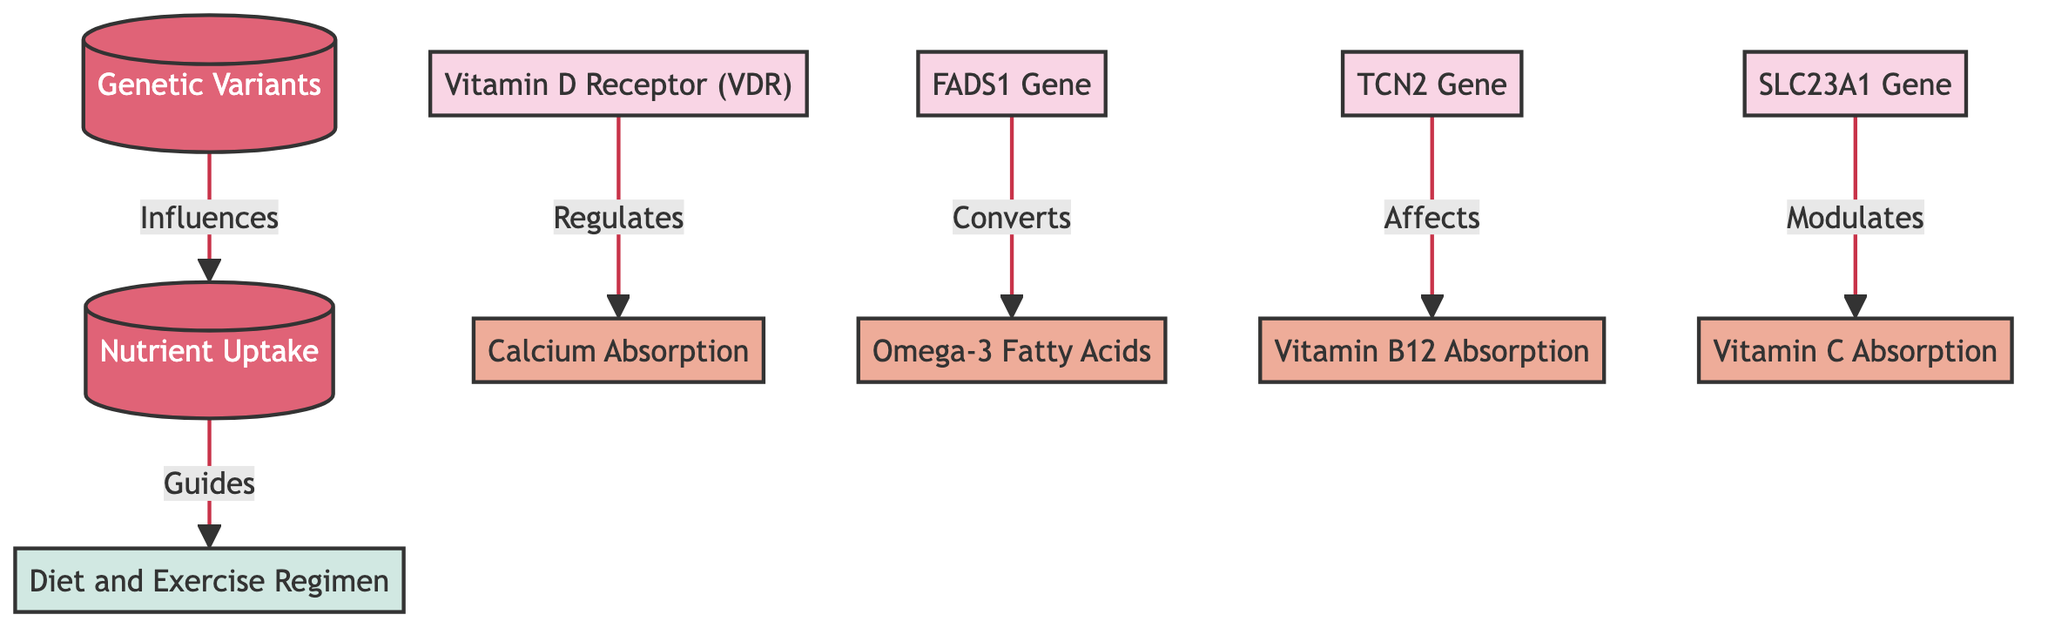What are the central nodes in the diagram? The central nodes in the diagram are "Genetic Variants" and "Nutrient Uptake". These are the nodes that are highlighted and placed at the center of the flowchart, indicating their primary importance.
Answer: Genetic Variants, Nutrient Uptake How many genetic variants are represented in the diagram? The diagram contains five genetic variants: "Vitamin D Receptor (VDR)", "FADS1 Gene", "TCN2 Gene", and "SLC23A1 Gene". Each of these is connected to specific nutrient uptake nodes.
Answer: 4 Which nutrient is affected by the TCN2 gene? The TCN2 gene is connected to "Vitamin B12 Absorption". This direct relationship indicates that this genetic variant has a regulatory role over the absorption of Vitamin B12.
Answer: Vitamin B12 Absorption What kind of relationship does the FADS1 gene have with Omega-3 fatty acids? The FADS1 gene is described as converting Omega-3 fatty acids, indicating a direct functional relationship between this genetic variant and the nutrient in question.
Answer: Converts How does nutrient uptake influence diet and exercise regimen? The diagram specifies that nutrient uptake guides diet and exercise regimen, indicating that the levels of nutrients absorbed can impact dietary choices and fitness activities undertaken by an individual.
Answer: Guides Which nutrient uptake is regulated by the Vitamin D Receptor (VDR)? The Vitamin D Receptor (VDR) regulates "Calcium Absorption", shown by the direct link from the VDR gene node to the calcium uptake node.
Answer: Calcium Absorption What other nutrient is influenced by the SLC23A1 gene? The SLC23A1 gene modulates "Vitamin C Absorption". This connection indicates that variations in the SLC23A1 gene can affect how well vitamin C is absorbed by the body.
Answer: Vitamin C Absorption What do the node colors signify in the diagram? In the diagram, the genetic variant nodes are colored in pink, while the nutrient uptake nodes are colored in orange, helping to visually distinguish between genetic influences and nutrient-related outcomes.
Answer: Different colors for genetic variants and nutrients What effect do the genetic variants have on nutrient uptake? The diagram indicates that genetic variants influence nutrient uptake, implying that specific genes may enhance or inhibit the absorption of particular vitamins and minerals.
Answer: Influences 